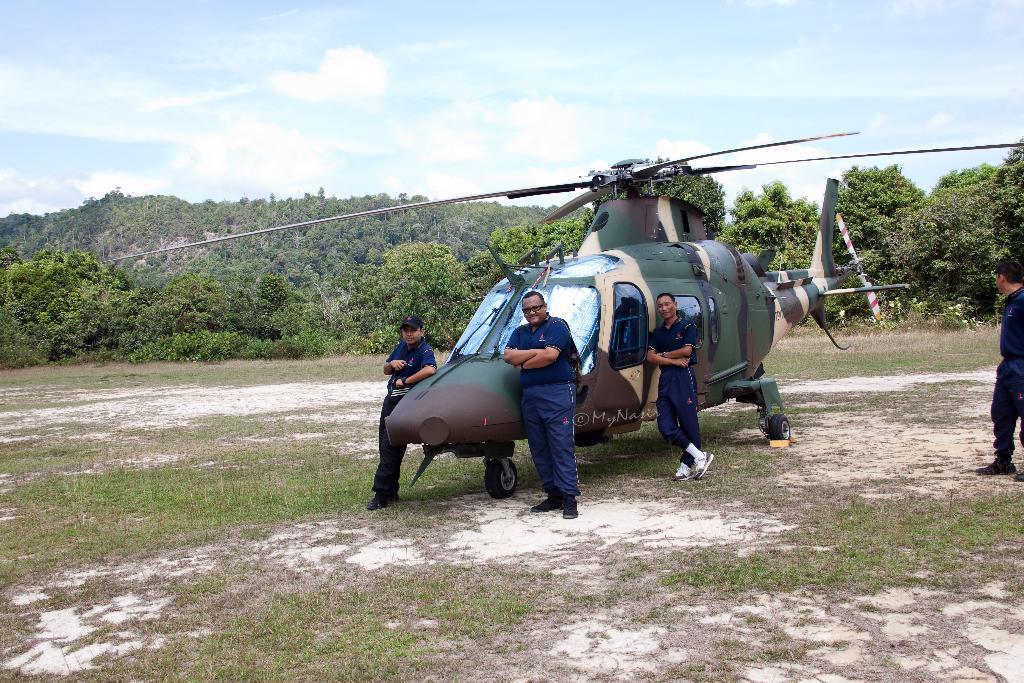Please provide a concise description of this image. In the image we can see there are people standing on the ground and beside them there is a helicopter. The ground is covered with grass and behind there are lot of trees. There is clear sky on the top. 